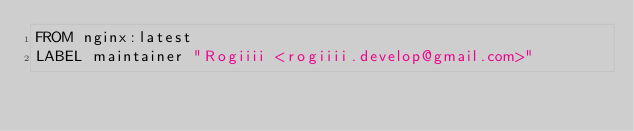<code> <loc_0><loc_0><loc_500><loc_500><_Dockerfile_>FROM nginx:latest
LABEL maintainer "Rogiiii <rogiiii.develop@gmail.com>"
</code> 